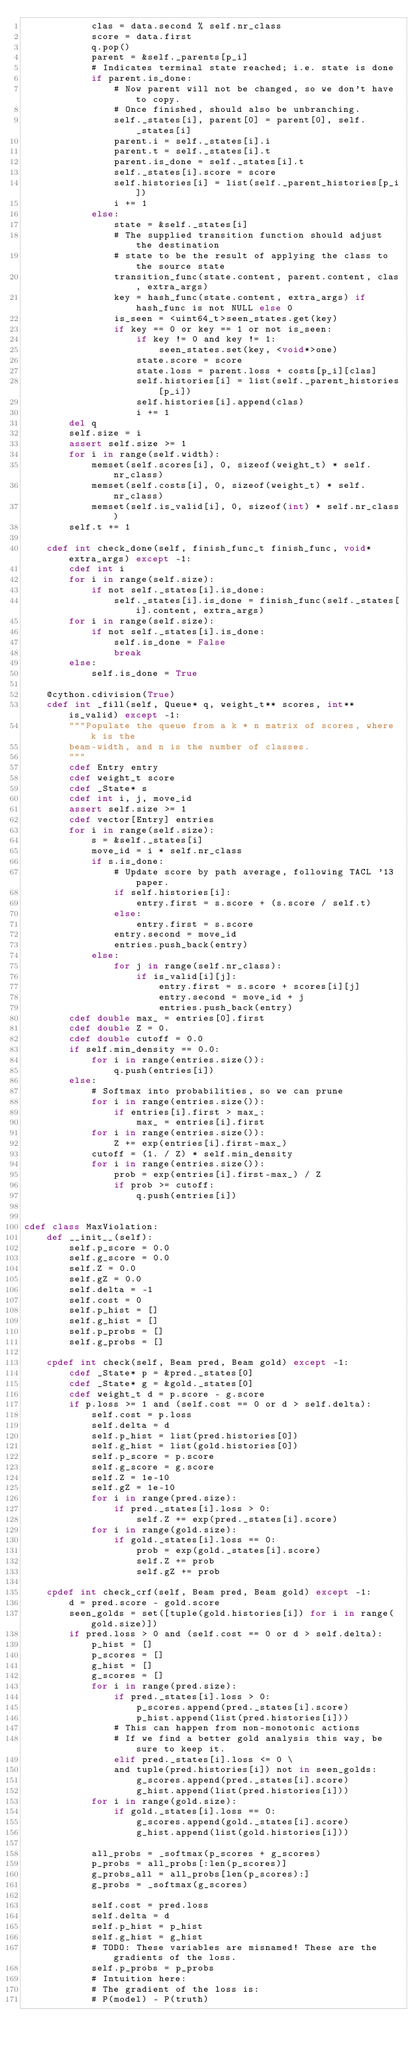Convert code to text. <code><loc_0><loc_0><loc_500><loc_500><_Cython_>            clas = data.second % self.nr_class
            score = data.first
            q.pop()
            parent = &self._parents[p_i]
            # Indicates terminal state reached; i.e. state is done
            if parent.is_done:
                # Now parent will not be changed, so we don't have to copy.
                # Once finished, should also be unbranching.
                self._states[i], parent[0] = parent[0], self._states[i]
                parent.i = self._states[i].i
                parent.t = self._states[i].t
                parent.is_done = self._states[i].t
                self._states[i].score = score
                self.histories[i] = list(self._parent_histories[p_i])
                i += 1
            else:
                state = &self._states[i]
                # The supplied transition function should adjust the destination
                # state to be the result of applying the class to the source state
                transition_func(state.content, parent.content, clas, extra_args)
                key = hash_func(state.content, extra_args) if hash_func is not NULL else 0
                is_seen = <uint64_t>seen_states.get(key)
                if key == 0 or key == 1 or not is_seen:
                    if key != 0 and key != 1:
                        seen_states.set(key, <void*>one)
                    state.score = score
                    state.loss = parent.loss + costs[p_i][clas]
                    self.histories[i] = list(self._parent_histories[p_i])
                    self.histories[i].append(clas)
                    i += 1
        del q
        self.size = i
        assert self.size >= 1
        for i in range(self.width):
            memset(self.scores[i], 0, sizeof(weight_t) * self.nr_class)
            memset(self.costs[i], 0, sizeof(weight_t) * self.nr_class)
            memset(self.is_valid[i], 0, sizeof(int) * self.nr_class)
        self.t += 1

    cdef int check_done(self, finish_func_t finish_func, void* extra_args) except -1:
        cdef int i
        for i in range(self.size):
            if not self._states[i].is_done:
                self._states[i].is_done = finish_func(self._states[i].content, extra_args)
        for i in range(self.size):
            if not self._states[i].is_done:
                self.is_done = False
                break
        else:
            self.is_done = True

    @cython.cdivision(True)
    cdef int _fill(self, Queue* q, weight_t** scores, int** is_valid) except -1:
        """Populate the queue from a k * n matrix of scores, where k is the
        beam-width, and n is the number of classes.
        """
        cdef Entry entry
        cdef weight_t score
        cdef _State* s
        cdef int i, j, move_id
        assert self.size >= 1
        cdef vector[Entry] entries
        for i in range(self.size):
            s = &self._states[i]
            move_id = i * self.nr_class
            if s.is_done:
                # Update score by path average, following TACL '13 paper.
                if self.histories[i]:
                    entry.first = s.score + (s.score / self.t)
                else:
                    entry.first = s.score
                entry.second = move_id
                entries.push_back(entry)
            else:
                for j in range(self.nr_class):
                    if is_valid[i][j]:
                        entry.first = s.score + scores[i][j]
                        entry.second = move_id + j
                        entries.push_back(entry)
        cdef double max_ = entries[0].first
        cdef double Z = 0.
        cdef double cutoff = 0.0
        if self.min_density == 0.0:
            for i in range(entries.size()):
                q.push(entries[i])
        else:
            # Softmax into probabilities, so we can prune
            for i in range(entries.size()):
                if entries[i].first > max_:
                    max_ = entries[i].first
            for i in range(entries.size()):
                Z += exp(entries[i].first-max_)
            cutoff = (1. / Z) * self.min_density
            for i in range(entries.size()):
                prob = exp(entries[i].first-max_) / Z
                if prob >= cutoff:
                    q.push(entries[i])


cdef class MaxViolation:
    def __init__(self):
        self.p_score = 0.0
        self.g_score = 0.0
        self.Z = 0.0
        self.gZ = 0.0
        self.delta = -1
        self.cost = 0
        self.p_hist = []
        self.g_hist = []
        self.p_probs = []
        self.g_probs = []

    cpdef int check(self, Beam pred, Beam gold) except -1:
        cdef _State* p = &pred._states[0]
        cdef _State* g = &gold._states[0]
        cdef weight_t d = p.score - g.score
        if p.loss >= 1 and (self.cost == 0 or d > self.delta):
            self.cost = p.loss
            self.delta = d
            self.p_hist = list(pred.histories[0])
            self.g_hist = list(gold.histories[0])
            self.p_score = p.score
            self.g_score = g.score
            self.Z = 1e-10
            self.gZ = 1e-10
            for i in range(pred.size):
                if pred._states[i].loss > 0:
                    self.Z += exp(pred._states[i].score)
            for i in range(gold.size):
                if gold._states[i].loss == 0:
                    prob = exp(gold._states[i].score)
                    self.Z += prob
                    self.gZ += prob

    cpdef int check_crf(self, Beam pred, Beam gold) except -1:
        d = pred.score - gold.score
        seen_golds = set([tuple(gold.histories[i]) for i in range(gold.size)])
        if pred.loss > 0 and (self.cost == 0 or d > self.delta):
            p_hist = []
            p_scores = []
            g_hist = []
            g_scores = []
            for i in range(pred.size):
                if pred._states[i].loss > 0:
                    p_scores.append(pred._states[i].score)
                    p_hist.append(list(pred.histories[i]))
                # This can happen from non-monotonic actions
                # If we find a better gold analysis this way, be sure to keep it.
                elif pred._states[i].loss <= 0 \
                and tuple(pred.histories[i]) not in seen_golds:
                    g_scores.append(pred._states[i].score)
                    g_hist.append(list(pred.histories[i]))
            for i in range(gold.size):
                if gold._states[i].loss == 0:
                    g_scores.append(gold._states[i].score)
                    g_hist.append(list(gold.histories[i]))

            all_probs = _softmax(p_scores + g_scores)
            p_probs = all_probs[:len(p_scores)]
            g_probs_all = all_probs[len(p_scores):]
            g_probs = _softmax(g_scores)

            self.cost = pred.loss
            self.delta = d
            self.p_hist = p_hist
            self.g_hist = g_hist
            # TODO: These variables are misnamed! These are the gradients of the loss.
            self.p_probs = p_probs
            # Intuition here:
            # The gradient of the loss is:
            # P(model) - P(truth)</code> 